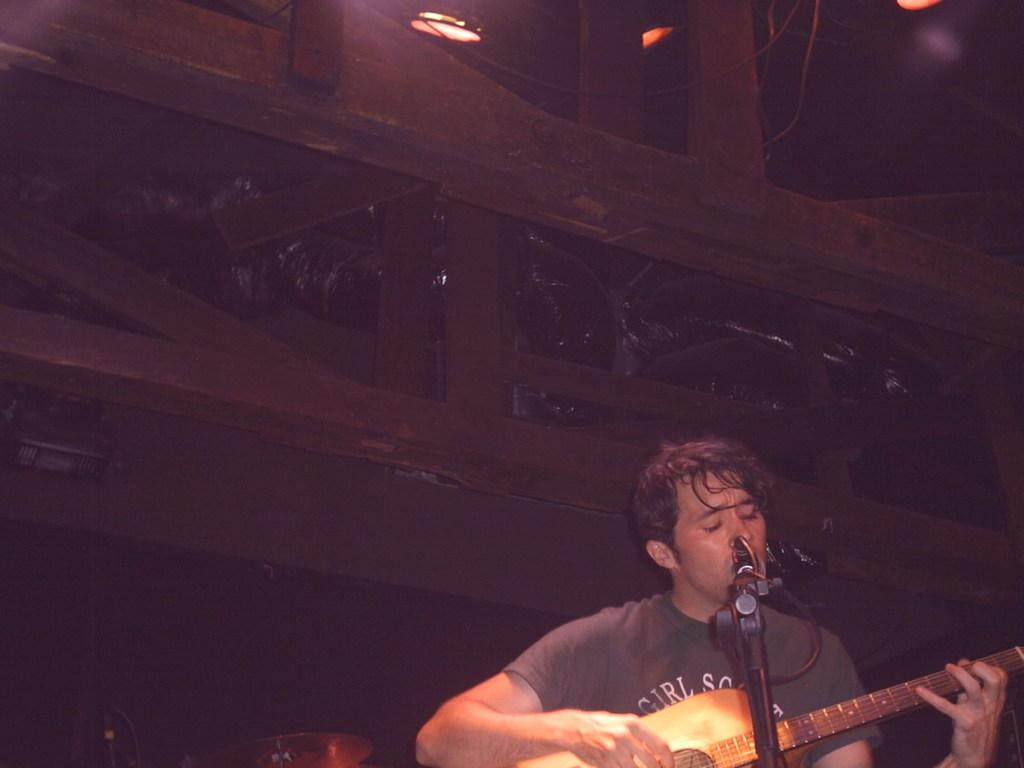Who is the main subject in the image? There is a boy in the image. Where is the boy positioned in the image? The boy is standing at the right side of the image. What is the boy holding in his hand? The boy is holding a guitar in his hand. What object is in front of the boy? There is a microphone (mic) in front of the boy. What type of camera is the boy using to take pictures in the image? There is no camera present in the image; the boy is holding a guitar and standing near a microphone. 